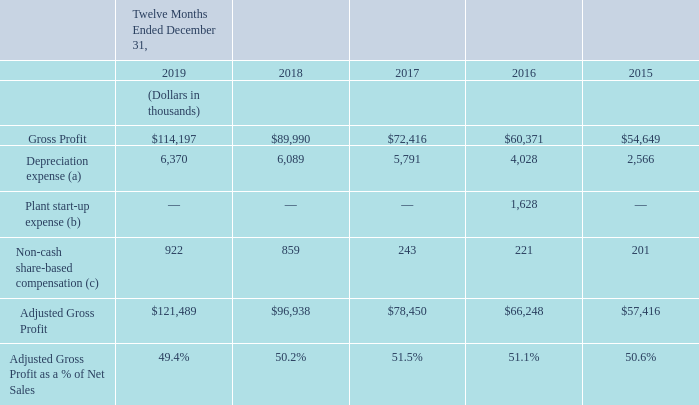The following table provides a reconciliation of Adjusted Gross Profit to Gross Profit, the most directly comparable financial measure presented in accordance with U.S. GAAP:
(a) Represents depreciation and amortization expense included in cost of goods sold
(b) Represents additional operating costs incurred in connection with the start-up of our new manufacturing lines as part of the Freshpet Kitchens expansion project in 2016 that included adding two additional product lines.
(c) Represents non-cash share-based compensation expense included in cost of goods sold.
What are the 3 expenses shown in the table? Depreciation expense, plant start-up expense, non-cash share-based compensation expense. What is the gross profit for each financial year end shown in the table (in chronological order)?
Answer scale should be: thousand. $54,649, $60,371, $72,416, $89,990, $114,197. What is the adjusted gross profit for each financial year end shown in the table (in chronological order)?
Answer scale should be: thousand. $57,416, $66,248, $78,450, $96,938, $121,489. What is the percentage change in depreciation expense from 2018 to 2019?
Answer scale should be: percent. (6,370-6,089)/6,089
Answer: 4.61. What is the percentage change in non-cash share-based compensation expense from 2018 to 2019?
Answer scale should be: percent. (922-859)/859
Answer: 7.33. What is the percentage change in adjusted gross profit from 2018 to 2019?
Answer scale should be: percent. (121,489-96,938)/96,938
Answer: 25.33. 